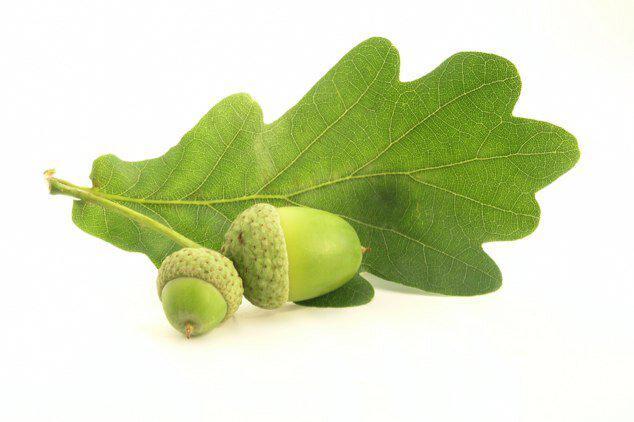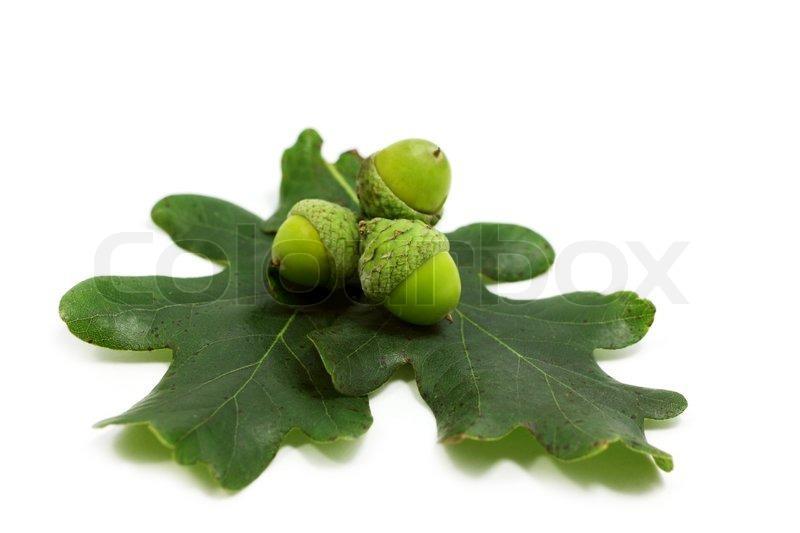The first image is the image on the left, the second image is the image on the right. Considering the images on both sides, is "The left and right image contains the same number of acorns." valid? Answer yes or no. No. The first image is the image on the left, the second image is the image on the right. For the images shown, is this caption "Each image shows at least two acorns and two acorn caps overlapping at least one green oak leaf." true? Answer yes or no. Yes. 